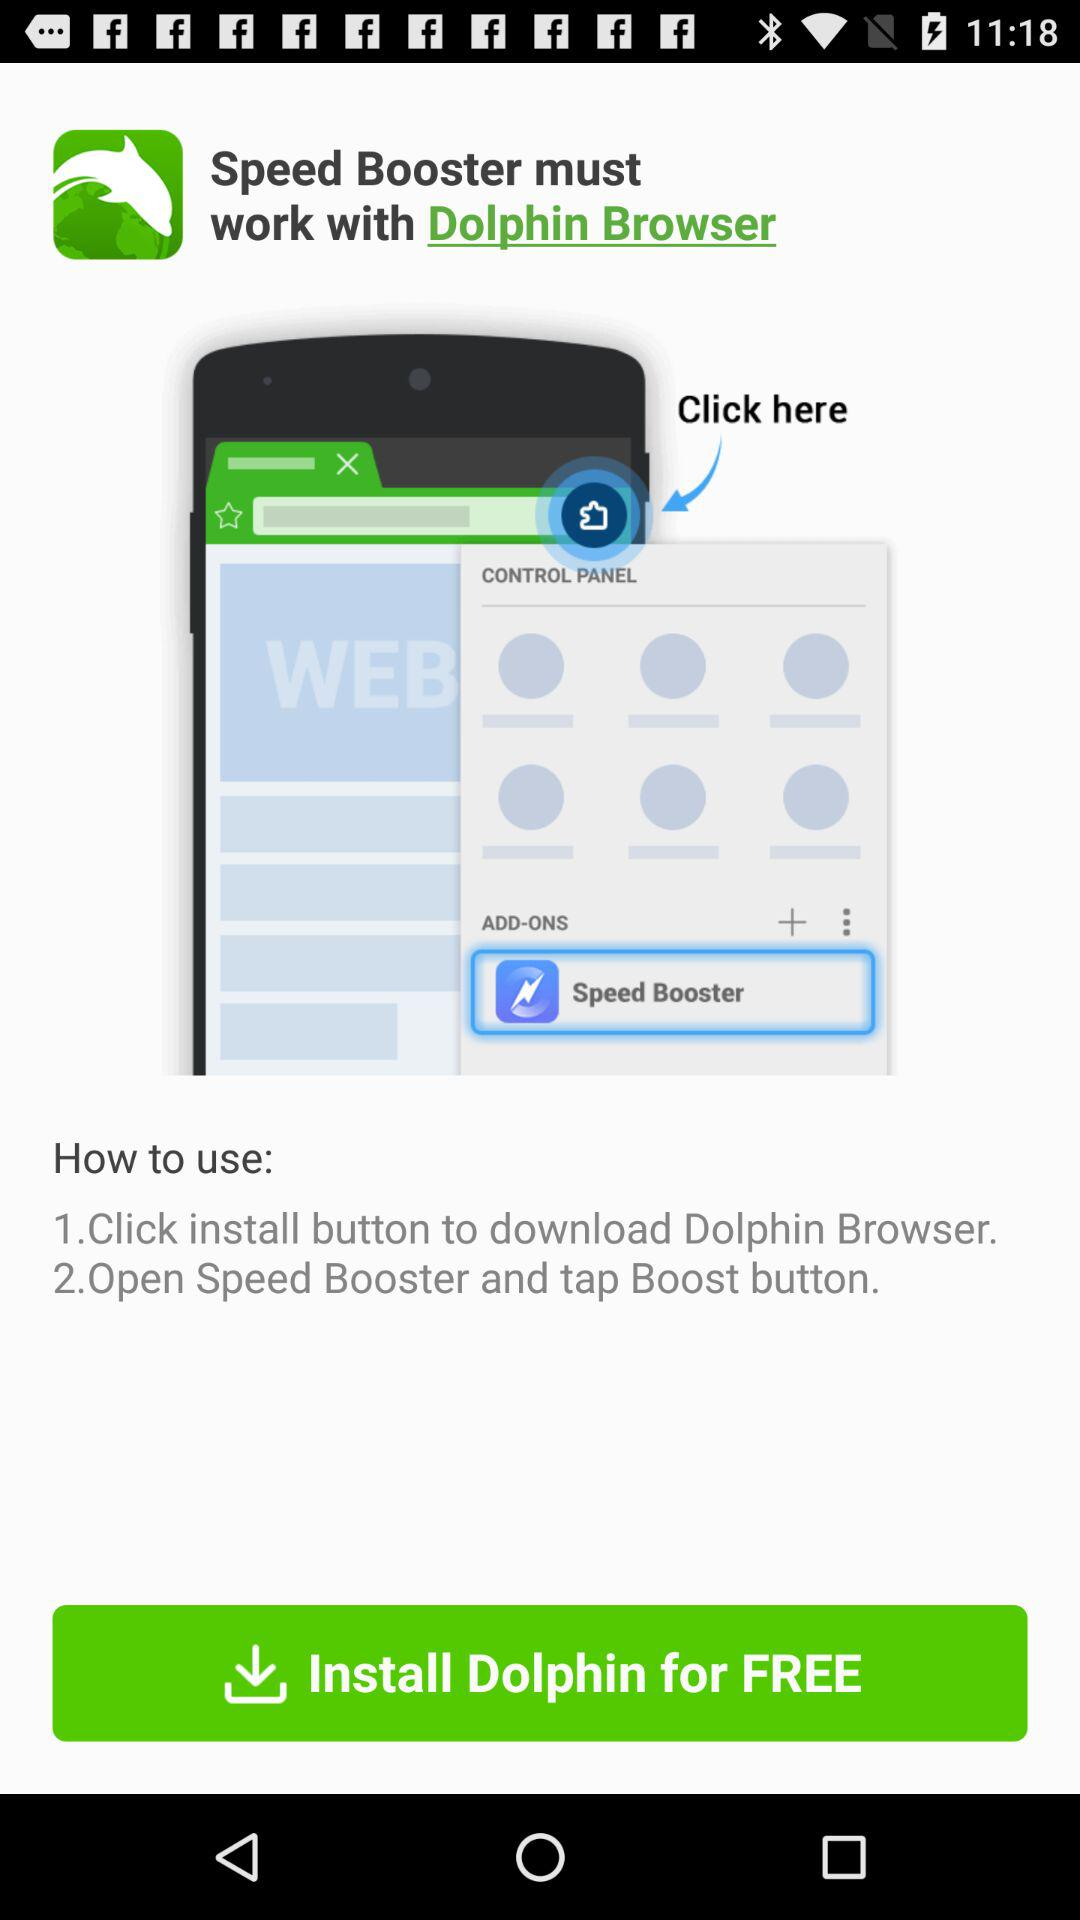How many steps are there in the instructions?
Answer the question using a single word or phrase. 2 